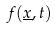Convert formula to latex. <formula><loc_0><loc_0><loc_500><loc_500>f ( \underline { x } , t )</formula> 